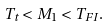Convert formula to latex. <formula><loc_0><loc_0><loc_500><loc_500>T _ { t } < M _ { 1 } < T _ { F I } .</formula> 